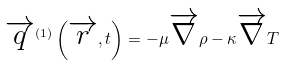Convert formula to latex. <formula><loc_0><loc_0><loc_500><loc_500>\overrightarrow { q } ^ { \left ( 1 \right ) } \left ( \overrightarrow { r } , t \right ) = - \mu \overrightarrow { \nabla } \rho - \kappa \overrightarrow { \nabla } T</formula> 